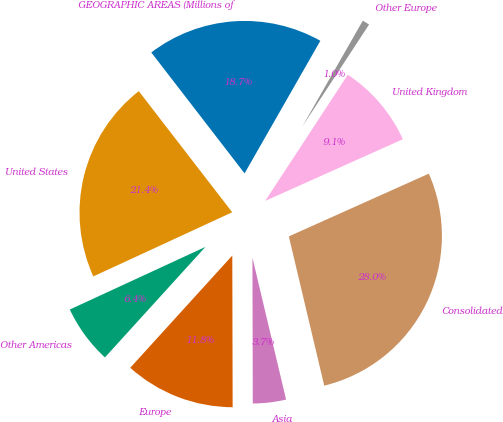<chart> <loc_0><loc_0><loc_500><loc_500><pie_chart><fcel>GEOGRAPHIC AREAS (Millions of<fcel>United States<fcel>Other Americas<fcel>Europe<fcel>Asia<fcel>Consolidated<fcel>United Kingdom<fcel>Other Europe<nl><fcel>18.72%<fcel>21.43%<fcel>6.37%<fcel>11.78%<fcel>3.67%<fcel>28.0%<fcel>9.07%<fcel>0.96%<nl></chart> 